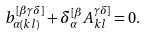<formula> <loc_0><loc_0><loc_500><loc_500>b _ { \alpha ( k l ) } ^ { [ \beta \gamma \delta ] } + \delta _ { \alpha } ^ { [ \beta } A _ { k l } ^ { \gamma \delta ] } = 0 .</formula> 